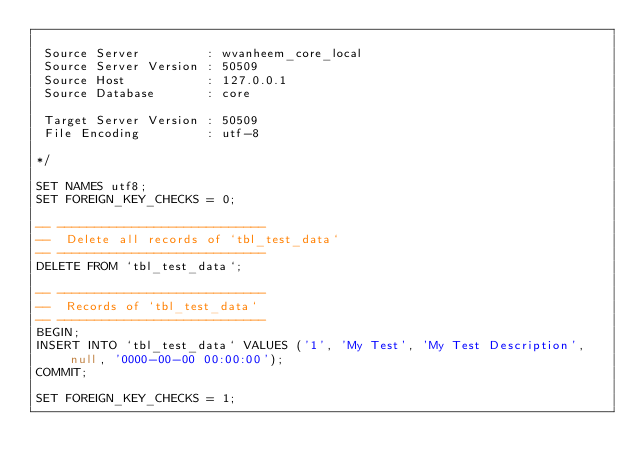Convert code to text. <code><loc_0><loc_0><loc_500><loc_500><_SQL_>
 Source Server         : wvanheem_core_local
 Source Server Version : 50509
 Source Host           : 127.0.0.1
 Source Database       : core

 Target Server Version : 50509
 File Encoding         : utf-8

*/

SET NAMES utf8;
SET FOREIGN_KEY_CHECKS = 0;

-- ----------------------------
--  Delete all records of `tbl_test_data`
-- ----------------------------
DELETE FROM `tbl_test_data`;

-- ----------------------------
--  Records of `tbl_test_data`
-- ----------------------------
BEGIN;
INSERT INTO `tbl_test_data` VALUES ('1', 'My Test', 'My Test Description', null, '0000-00-00 00:00:00');
COMMIT;

SET FOREIGN_KEY_CHECKS = 1;
</code> 